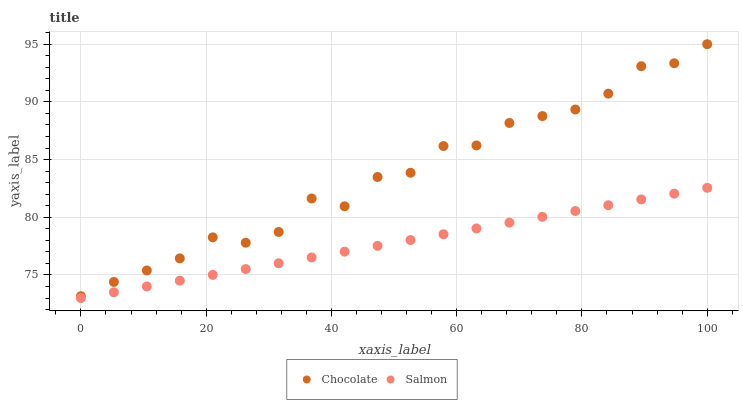Does Salmon have the minimum area under the curve?
Answer yes or no. Yes. Does Chocolate have the maximum area under the curve?
Answer yes or no. Yes. Does Chocolate have the minimum area under the curve?
Answer yes or no. No. Is Salmon the smoothest?
Answer yes or no. Yes. Is Chocolate the roughest?
Answer yes or no. Yes. Is Chocolate the smoothest?
Answer yes or no. No. Does Salmon have the lowest value?
Answer yes or no. Yes. Does Chocolate have the lowest value?
Answer yes or no. No. Does Chocolate have the highest value?
Answer yes or no. Yes. Is Salmon less than Chocolate?
Answer yes or no. Yes. Is Chocolate greater than Salmon?
Answer yes or no. Yes. Does Salmon intersect Chocolate?
Answer yes or no. No. 